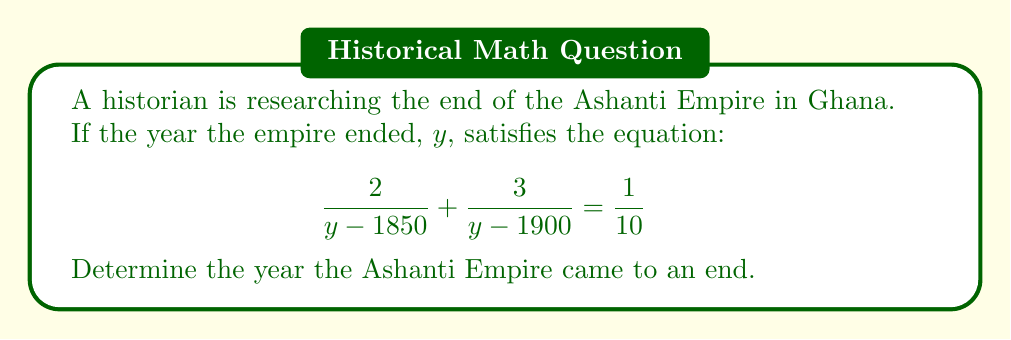Provide a solution to this math problem. Let's solve this step-by-step:

1) First, we need to find a common denominator. The least common multiple of $(y - 1850)$ and $(y - 1900)$ is $(y - 1850)(y - 1900)$. Multiply both sides by this:

   $$\left(\frac{2}{y - 1850} + \frac{3}{y - 1900}\right)(y - 1850)(y - 1900) = \frac{1}{10}(y - 1850)(y - 1900)$$

2) Simplify:

   $$2(y - 1900) + 3(y - 1850) = \frac{1}{10}(y - 1850)(y - 1900)$$

3) Expand the left side:

   $$2y - 3800 + 3y - 5550 = \frac{1}{10}(y^2 - 3750y + 3515000)$$

4) Simplify:

   $$5y - 9350 = \frac{1}{10}(y^2 - 3750y + 3515000)$$

5) Multiply both sides by 10:

   $$50y - 93500 = y^2 - 3750y + 3515000$$

6) Rearrange to standard form:

   $$y^2 - 3800y + 3608500 = 0$$

7) This is a quadratic equation. We can solve it using the quadratic formula: $y = \frac{-b \pm \sqrt{b^2 - 4ac}}{2a}$

   Where $a = 1$, $b = -3800$, and $c = 3608500$

8) Plugging in:

   $$y = \frac{3800 \pm \sqrt{3800^2 - 4(1)(3608500)}}{2(1)}$$

9) Simplify:

   $$y = \frac{3800 \pm \sqrt{14440000 - 14434000}}{2} = \frac{3800 \pm \sqrt{6000}}{2}$$

10) Further simplify:

    $$y = \frac{3800 \pm 77.46}{2}$$

11) This gives us two solutions:

    $$y = 1938.73 \text{ or } y = 1861.27$$

12) Since we're looking for a year, and the Ashanti Empire existed into the 20th century, we round 1938.73 to 1939.
Answer: 1939 